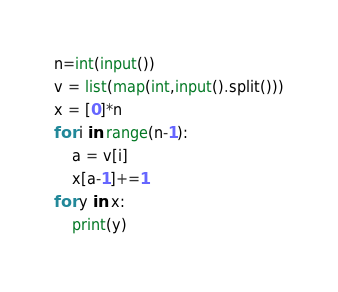<code> <loc_0><loc_0><loc_500><loc_500><_Python_>n=int(input())
v = list(map(int,input().split()))
x = [0]*n
for i in range(n-1):
    a = v[i]
    x[a-1]+=1
for y in x:
    print(y)</code> 